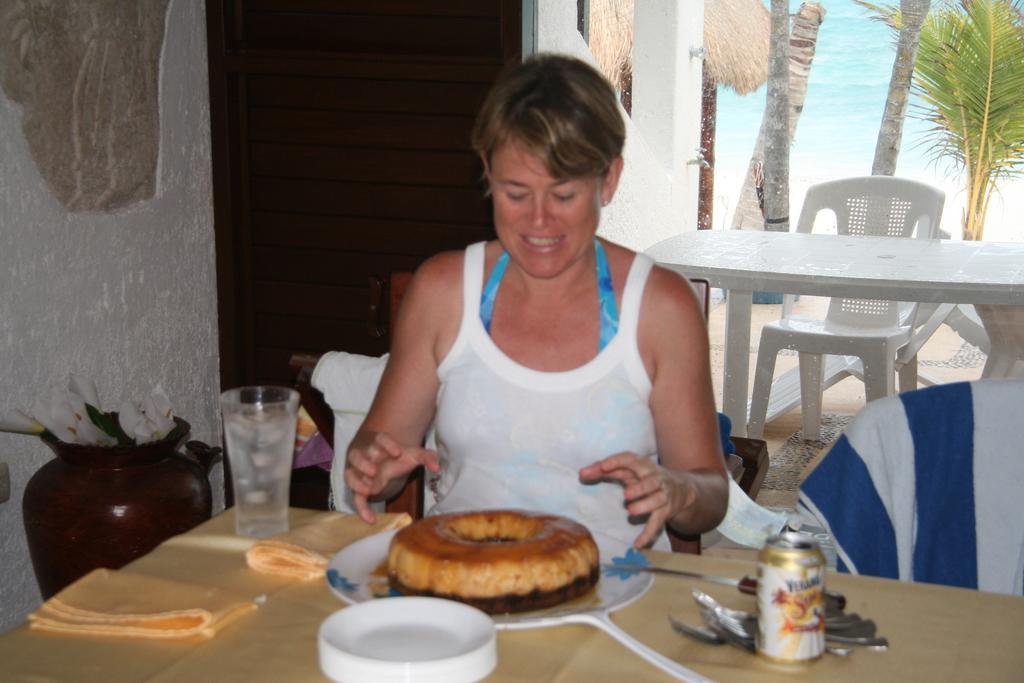Please provide a concise description of this image. In this image I can see the person sitting and the person is wearing white and blue color dress. In front I can see the food in the plate and the food is in brown color and I can also see the tin, few plates and the glass on the table. In the background I can see the wall in white color and I can also see few flowers, a chair and the table and I can see few plants in green color and the water is in blue color. 